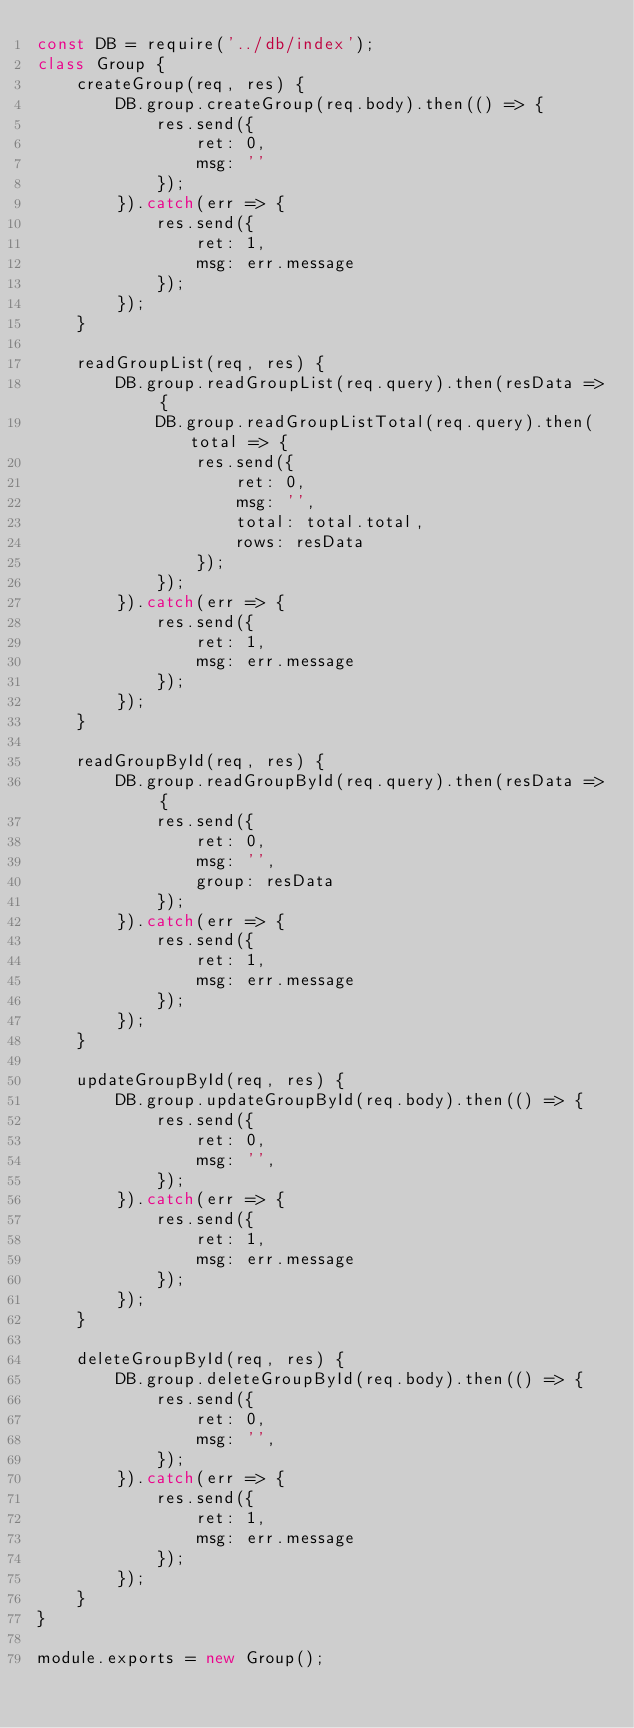Convert code to text. <code><loc_0><loc_0><loc_500><loc_500><_JavaScript_>const DB = require('../db/index');
class Group {
    createGroup(req, res) {
        DB.group.createGroup(req.body).then(() => {
            res.send({
                ret: 0,
                msg: ''
            });
        }).catch(err => {
            res.send({
                ret: 1,
                msg: err.message
            });
        });
    }

    readGroupList(req, res) {
        DB.group.readGroupList(req.query).then(resData => {
            DB.group.readGroupListTotal(req.query).then(total => {
                res.send({
                    ret: 0,
                    msg: '',
                    total: total.total,
                    rows: resData
                });
            });
        }).catch(err => {
            res.send({
                ret: 1,
                msg: err.message
            });
        });
    }

    readGroupById(req, res) {
        DB.group.readGroupById(req.query).then(resData => {
            res.send({
                ret: 0,
                msg: '',
                group: resData
            });
        }).catch(err => {
            res.send({
                ret: 1,
                msg: err.message
            });
        });
    }

    updateGroupById(req, res) {
        DB.group.updateGroupById(req.body).then(() => {
            res.send({
                ret: 0,
                msg: '',
            });
        }).catch(err => {
            res.send({
                ret: 1,
                msg: err.message
            });
        });
    }

    deleteGroupById(req, res) {
        DB.group.deleteGroupById(req.body).then(() => {
            res.send({
                ret: 0,
                msg: '',
            });
        }).catch(err => {
            res.send({
                ret: 1,
                msg: err.message
            });
        });
    }
}

module.exports = new Group();

</code> 